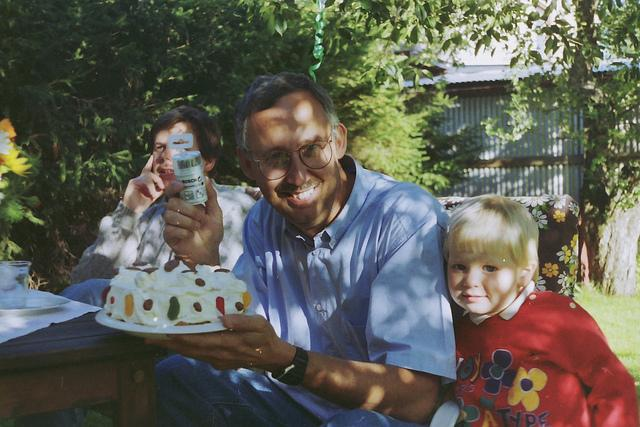What this man doing? celebrating 